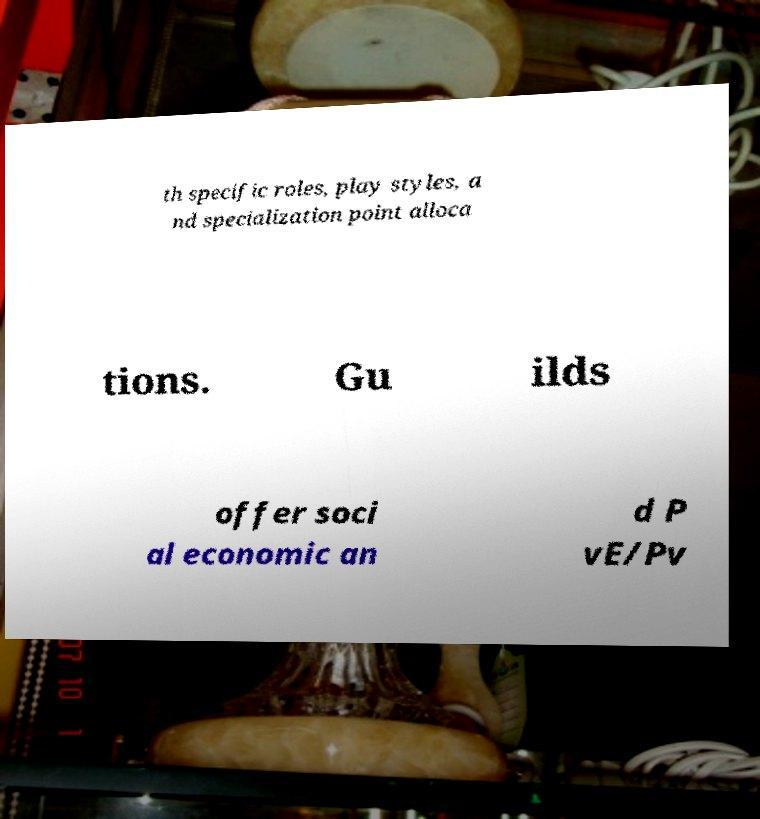Could you assist in decoding the text presented in this image and type it out clearly? th specific roles, play styles, a nd specialization point alloca tions. Gu ilds offer soci al economic an d P vE/Pv 